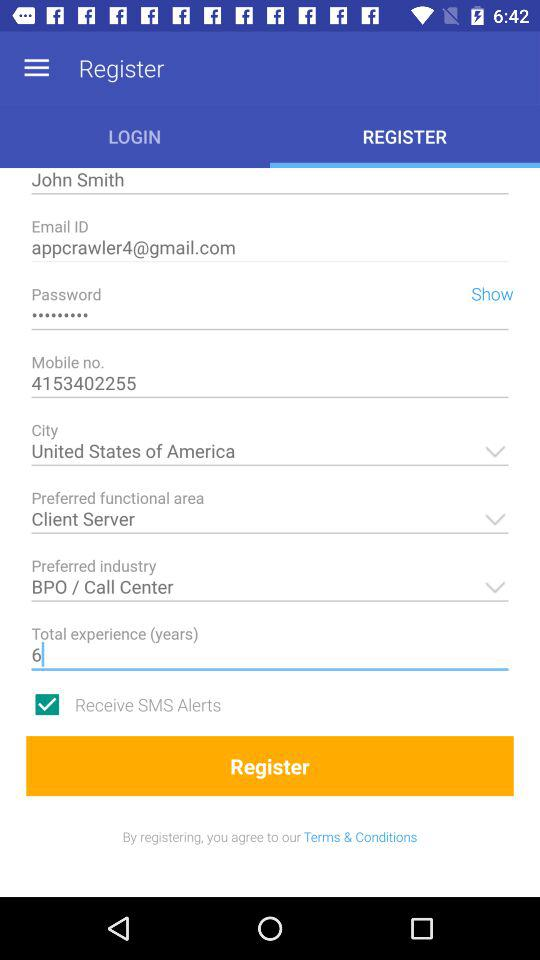Which is the preferred functional area? The preferred functional area is client-server. 